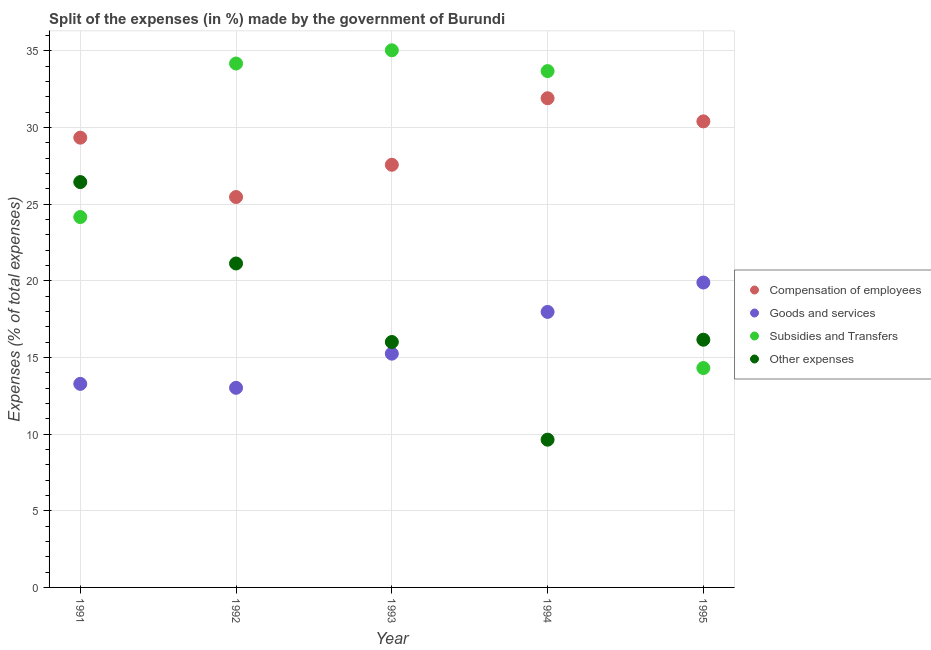What is the percentage of amount spent on compensation of employees in 1995?
Offer a very short reply. 30.4. Across all years, what is the maximum percentage of amount spent on goods and services?
Offer a terse response. 19.89. Across all years, what is the minimum percentage of amount spent on subsidies?
Provide a succinct answer. 14.31. In which year was the percentage of amount spent on goods and services maximum?
Your answer should be compact. 1995. In which year was the percentage of amount spent on compensation of employees minimum?
Provide a short and direct response. 1992. What is the total percentage of amount spent on subsidies in the graph?
Make the answer very short. 141.35. What is the difference between the percentage of amount spent on other expenses in 1991 and that in 1993?
Ensure brevity in your answer.  10.43. What is the difference between the percentage of amount spent on compensation of employees in 1992 and the percentage of amount spent on other expenses in 1991?
Make the answer very short. -0.98. What is the average percentage of amount spent on goods and services per year?
Your answer should be compact. 15.88. In the year 1991, what is the difference between the percentage of amount spent on other expenses and percentage of amount spent on goods and services?
Offer a very short reply. 13.16. In how many years, is the percentage of amount spent on compensation of employees greater than 22 %?
Offer a terse response. 5. What is the ratio of the percentage of amount spent on subsidies in 1991 to that in 1993?
Your response must be concise. 0.69. Is the percentage of amount spent on compensation of employees in 1993 less than that in 1994?
Your response must be concise. Yes. Is the difference between the percentage of amount spent on goods and services in 1992 and 1995 greater than the difference between the percentage of amount spent on compensation of employees in 1992 and 1995?
Make the answer very short. No. What is the difference between the highest and the second highest percentage of amount spent on other expenses?
Offer a terse response. 5.31. What is the difference between the highest and the lowest percentage of amount spent on goods and services?
Give a very brief answer. 6.87. In how many years, is the percentage of amount spent on goods and services greater than the average percentage of amount spent on goods and services taken over all years?
Offer a very short reply. 2. Is it the case that in every year, the sum of the percentage of amount spent on subsidies and percentage of amount spent on compensation of employees is greater than the sum of percentage of amount spent on goods and services and percentage of amount spent on other expenses?
Your answer should be compact. No. Is it the case that in every year, the sum of the percentage of amount spent on compensation of employees and percentage of amount spent on goods and services is greater than the percentage of amount spent on subsidies?
Give a very brief answer. Yes. Does the percentage of amount spent on goods and services monotonically increase over the years?
Provide a succinct answer. No. Is the percentage of amount spent on subsidies strictly greater than the percentage of amount spent on other expenses over the years?
Make the answer very short. No. Is the percentage of amount spent on subsidies strictly less than the percentage of amount spent on other expenses over the years?
Your answer should be compact. No. How many years are there in the graph?
Provide a succinct answer. 5. What is the difference between two consecutive major ticks on the Y-axis?
Your answer should be compact. 5. Where does the legend appear in the graph?
Your answer should be compact. Center right. What is the title of the graph?
Your response must be concise. Split of the expenses (in %) made by the government of Burundi. Does "PFC gas" appear as one of the legend labels in the graph?
Keep it short and to the point. No. What is the label or title of the X-axis?
Your answer should be very brief. Year. What is the label or title of the Y-axis?
Make the answer very short. Expenses (% of total expenses). What is the Expenses (% of total expenses) in Compensation of employees in 1991?
Provide a short and direct response. 29.34. What is the Expenses (% of total expenses) in Goods and services in 1991?
Your answer should be compact. 13.28. What is the Expenses (% of total expenses) in Subsidies and Transfers in 1991?
Make the answer very short. 24.16. What is the Expenses (% of total expenses) in Other expenses in 1991?
Provide a succinct answer. 26.44. What is the Expenses (% of total expenses) of Compensation of employees in 1992?
Keep it short and to the point. 25.46. What is the Expenses (% of total expenses) in Goods and services in 1992?
Provide a succinct answer. 13.02. What is the Expenses (% of total expenses) of Subsidies and Transfers in 1992?
Your answer should be compact. 34.17. What is the Expenses (% of total expenses) in Other expenses in 1992?
Keep it short and to the point. 21.13. What is the Expenses (% of total expenses) of Compensation of employees in 1993?
Keep it short and to the point. 27.57. What is the Expenses (% of total expenses) of Goods and services in 1993?
Keep it short and to the point. 15.25. What is the Expenses (% of total expenses) of Subsidies and Transfers in 1993?
Ensure brevity in your answer.  35.03. What is the Expenses (% of total expenses) of Other expenses in 1993?
Keep it short and to the point. 16.01. What is the Expenses (% of total expenses) in Compensation of employees in 1994?
Your answer should be very brief. 31.91. What is the Expenses (% of total expenses) of Goods and services in 1994?
Ensure brevity in your answer.  17.97. What is the Expenses (% of total expenses) in Subsidies and Transfers in 1994?
Give a very brief answer. 33.68. What is the Expenses (% of total expenses) of Other expenses in 1994?
Keep it short and to the point. 9.64. What is the Expenses (% of total expenses) of Compensation of employees in 1995?
Keep it short and to the point. 30.4. What is the Expenses (% of total expenses) in Goods and services in 1995?
Your response must be concise. 19.89. What is the Expenses (% of total expenses) of Subsidies and Transfers in 1995?
Offer a terse response. 14.31. What is the Expenses (% of total expenses) of Other expenses in 1995?
Ensure brevity in your answer.  16.16. Across all years, what is the maximum Expenses (% of total expenses) in Compensation of employees?
Your response must be concise. 31.91. Across all years, what is the maximum Expenses (% of total expenses) of Goods and services?
Provide a succinct answer. 19.89. Across all years, what is the maximum Expenses (% of total expenses) of Subsidies and Transfers?
Ensure brevity in your answer.  35.03. Across all years, what is the maximum Expenses (% of total expenses) of Other expenses?
Your answer should be compact. 26.44. Across all years, what is the minimum Expenses (% of total expenses) in Compensation of employees?
Your response must be concise. 25.46. Across all years, what is the minimum Expenses (% of total expenses) in Goods and services?
Your answer should be very brief. 13.02. Across all years, what is the minimum Expenses (% of total expenses) in Subsidies and Transfers?
Your answer should be very brief. 14.31. Across all years, what is the minimum Expenses (% of total expenses) of Other expenses?
Give a very brief answer. 9.64. What is the total Expenses (% of total expenses) of Compensation of employees in the graph?
Provide a succinct answer. 144.67. What is the total Expenses (% of total expenses) in Goods and services in the graph?
Make the answer very short. 79.4. What is the total Expenses (% of total expenses) of Subsidies and Transfers in the graph?
Make the answer very short. 141.35. What is the total Expenses (% of total expenses) of Other expenses in the graph?
Offer a very short reply. 89.37. What is the difference between the Expenses (% of total expenses) of Compensation of employees in 1991 and that in 1992?
Offer a terse response. 3.87. What is the difference between the Expenses (% of total expenses) in Goods and services in 1991 and that in 1992?
Provide a short and direct response. 0.26. What is the difference between the Expenses (% of total expenses) in Subsidies and Transfers in 1991 and that in 1992?
Your answer should be very brief. -10.01. What is the difference between the Expenses (% of total expenses) of Other expenses in 1991 and that in 1992?
Your answer should be very brief. 5.31. What is the difference between the Expenses (% of total expenses) in Compensation of employees in 1991 and that in 1993?
Your answer should be compact. 1.77. What is the difference between the Expenses (% of total expenses) in Goods and services in 1991 and that in 1993?
Keep it short and to the point. -1.97. What is the difference between the Expenses (% of total expenses) in Subsidies and Transfers in 1991 and that in 1993?
Your answer should be very brief. -10.88. What is the difference between the Expenses (% of total expenses) in Other expenses in 1991 and that in 1993?
Make the answer very short. 10.43. What is the difference between the Expenses (% of total expenses) in Compensation of employees in 1991 and that in 1994?
Make the answer very short. -2.57. What is the difference between the Expenses (% of total expenses) in Goods and services in 1991 and that in 1994?
Keep it short and to the point. -4.69. What is the difference between the Expenses (% of total expenses) of Subsidies and Transfers in 1991 and that in 1994?
Your response must be concise. -9.52. What is the difference between the Expenses (% of total expenses) of Other expenses in 1991 and that in 1994?
Ensure brevity in your answer.  16.8. What is the difference between the Expenses (% of total expenses) of Compensation of employees in 1991 and that in 1995?
Provide a succinct answer. -1.06. What is the difference between the Expenses (% of total expenses) in Goods and services in 1991 and that in 1995?
Offer a terse response. -6.61. What is the difference between the Expenses (% of total expenses) in Subsidies and Transfers in 1991 and that in 1995?
Your answer should be very brief. 9.85. What is the difference between the Expenses (% of total expenses) of Other expenses in 1991 and that in 1995?
Offer a terse response. 10.28. What is the difference between the Expenses (% of total expenses) of Compensation of employees in 1992 and that in 1993?
Your answer should be very brief. -2.1. What is the difference between the Expenses (% of total expenses) of Goods and services in 1992 and that in 1993?
Keep it short and to the point. -2.23. What is the difference between the Expenses (% of total expenses) of Subsidies and Transfers in 1992 and that in 1993?
Give a very brief answer. -0.86. What is the difference between the Expenses (% of total expenses) of Other expenses in 1992 and that in 1993?
Offer a very short reply. 5.12. What is the difference between the Expenses (% of total expenses) of Compensation of employees in 1992 and that in 1994?
Your answer should be very brief. -6.44. What is the difference between the Expenses (% of total expenses) in Goods and services in 1992 and that in 1994?
Give a very brief answer. -4.95. What is the difference between the Expenses (% of total expenses) of Subsidies and Transfers in 1992 and that in 1994?
Keep it short and to the point. 0.49. What is the difference between the Expenses (% of total expenses) in Other expenses in 1992 and that in 1994?
Keep it short and to the point. 11.49. What is the difference between the Expenses (% of total expenses) of Compensation of employees in 1992 and that in 1995?
Your answer should be very brief. -4.93. What is the difference between the Expenses (% of total expenses) in Goods and services in 1992 and that in 1995?
Provide a short and direct response. -6.87. What is the difference between the Expenses (% of total expenses) of Subsidies and Transfers in 1992 and that in 1995?
Your answer should be compact. 19.86. What is the difference between the Expenses (% of total expenses) of Other expenses in 1992 and that in 1995?
Provide a succinct answer. 4.97. What is the difference between the Expenses (% of total expenses) in Compensation of employees in 1993 and that in 1994?
Keep it short and to the point. -4.34. What is the difference between the Expenses (% of total expenses) of Goods and services in 1993 and that in 1994?
Ensure brevity in your answer.  -2.72. What is the difference between the Expenses (% of total expenses) of Subsidies and Transfers in 1993 and that in 1994?
Provide a succinct answer. 1.36. What is the difference between the Expenses (% of total expenses) in Other expenses in 1993 and that in 1994?
Offer a very short reply. 6.37. What is the difference between the Expenses (% of total expenses) of Compensation of employees in 1993 and that in 1995?
Give a very brief answer. -2.83. What is the difference between the Expenses (% of total expenses) in Goods and services in 1993 and that in 1995?
Provide a succinct answer. -4.64. What is the difference between the Expenses (% of total expenses) of Subsidies and Transfers in 1993 and that in 1995?
Offer a very short reply. 20.73. What is the difference between the Expenses (% of total expenses) of Other expenses in 1993 and that in 1995?
Provide a succinct answer. -0.15. What is the difference between the Expenses (% of total expenses) in Compensation of employees in 1994 and that in 1995?
Your response must be concise. 1.51. What is the difference between the Expenses (% of total expenses) of Goods and services in 1994 and that in 1995?
Your response must be concise. -1.92. What is the difference between the Expenses (% of total expenses) in Subsidies and Transfers in 1994 and that in 1995?
Keep it short and to the point. 19.37. What is the difference between the Expenses (% of total expenses) in Other expenses in 1994 and that in 1995?
Keep it short and to the point. -6.52. What is the difference between the Expenses (% of total expenses) in Compensation of employees in 1991 and the Expenses (% of total expenses) in Goods and services in 1992?
Your answer should be very brief. 16.32. What is the difference between the Expenses (% of total expenses) of Compensation of employees in 1991 and the Expenses (% of total expenses) of Subsidies and Transfers in 1992?
Give a very brief answer. -4.84. What is the difference between the Expenses (% of total expenses) of Compensation of employees in 1991 and the Expenses (% of total expenses) of Other expenses in 1992?
Offer a terse response. 8.21. What is the difference between the Expenses (% of total expenses) in Goods and services in 1991 and the Expenses (% of total expenses) in Subsidies and Transfers in 1992?
Your answer should be very brief. -20.89. What is the difference between the Expenses (% of total expenses) of Goods and services in 1991 and the Expenses (% of total expenses) of Other expenses in 1992?
Ensure brevity in your answer.  -7.85. What is the difference between the Expenses (% of total expenses) in Subsidies and Transfers in 1991 and the Expenses (% of total expenses) in Other expenses in 1992?
Keep it short and to the point. 3.03. What is the difference between the Expenses (% of total expenses) in Compensation of employees in 1991 and the Expenses (% of total expenses) in Goods and services in 1993?
Offer a terse response. 14.09. What is the difference between the Expenses (% of total expenses) in Compensation of employees in 1991 and the Expenses (% of total expenses) in Subsidies and Transfers in 1993?
Offer a very short reply. -5.7. What is the difference between the Expenses (% of total expenses) of Compensation of employees in 1991 and the Expenses (% of total expenses) of Other expenses in 1993?
Provide a short and direct response. 13.33. What is the difference between the Expenses (% of total expenses) in Goods and services in 1991 and the Expenses (% of total expenses) in Subsidies and Transfers in 1993?
Your answer should be compact. -21.76. What is the difference between the Expenses (% of total expenses) in Goods and services in 1991 and the Expenses (% of total expenses) in Other expenses in 1993?
Your answer should be very brief. -2.73. What is the difference between the Expenses (% of total expenses) in Subsidies and Transfers in 1991 and the Expenses (% of total expenses) in Other expenses in 1993?
Provide a succinct answer. 8.15. What is the difference between the Expenses (% of total expenses) in Compensation of employees in 1991 and the Expenses (% of total expenses) in Goods and services in 1994?
Offer a terse response. 11.37. What is the difference between the Expenses (% of total expenses) in Compensation of employees in 1991 and the Expenses (% of total expenses) in Subsidies and Transfers in 1994?
Offer a very short reply. -4.34. What is the difference between the Expenses (% of total expenses) in Compensation of employees in 1991 and the Expenses (% of total expenses) in Other expenses in 1994?
Keep it short and to the point. 19.7. What is the difference between the Expenses (% of total expenses) in Goods and services in 1991 and the Expenses (% of total expenses) in Subsidies and Transfers in 1994?
Provide a succinct answer. -20.4. What is the difference between the Expenses (% of total expenses) of Goods and services in 1991 and the Expenses (% of total expenses) of Other expenses in 1994?
Your answer should be compact. 3.64. What is the difference between the Expenses (% of total expenses) in Subsidies and Transfers in 1991 and the Expenses (% of total expenses) in Other expenses in 1994?
Keep it short and to the point. 14.52. What is the difference between the Expenses (% of total expenses) of Compensation of employees in 1991 and the Expenses (% of total expenses) of Goods and services in 1995?
Provide a short and direct response. 9.45. What is the difference between the Expenses (% of total expenses) in Compensation of employees in 1991 and the Expenses (% of total expenses) in Subsidies and Transfers in 1995?
Provide a succinct answer. 15.03. What is the difference between the Expenses (% of total expenses) of Compensation of employees in 1991 and the Expenses (% of total expenses) of Other expenses in 1995?
Give a very brief answer. 13.18. What is the difference between the Expenses (% of total expenses) in Goods and services in 1991 and the Expenses (% of total expenses) in Subsidies and Transfers in 1995?
Offer a very short reply. -1.03. What is the difference between the Expenses (% of total expenses) in Goods and services in 1991 and the Expenses (% of total expenses) in Other expenses in 1995?
Give a very brief answer. -2.88. What is the difference between the Expenses (% of total expenses) in Subsidies and Transfers in 1991 and the Expenses (% of total expenses) in Other expenses in 1995?
Give a very brief answer. 8. What is the difference between the Expenses (% of total expenses) of Compensation of employees in 1992 and the Expenses (% of total expenses) of Goods and services in 1993?
Your answer should be very brief. 10.22. What is the difference between the Expenses (% of total expenses) of Compensation of employees in 1992 and the Expenses (% of total expenses) of Subsidies and Transfers in 1993?
Keep it short and to the point. -9.57. What is the difference between the Expenses (% of total expenses) of Compensation of employees in 1992 and the Expenses (% of total expenses) of Other expenses in 1993?
Your answer should be compact. 9.46. What is the difference between the Expenses (% of total expenses) in Goods and services in 1992 and the Expenses (% of total expenses) in Subsidies and Transfers in 1993?
Ensure brevity in your answer.  -22.01. What is the difference between the Expenses (% of total expenses) of Goods and services in 1992 and the Expenses (% of total expenses) of Other expenses in 1993?
Keep it short and to the point. -2.99. What is the difference between the Expenses (% of total expenses) in Subsidies and Transfers in 1992 and the Expenses (% of total expenses) in Other expenses in 1993?
Provide a succinct answer. 18.16. What is the difference between the Expenses (% of total expenses) of Compensation of employees in 1992 and the Expenses (% of total expenses) of Goods and services in 1994?
Offer a very short reply. 7.49. What is the difference between the Expenses (% of total expenses) in Compensation of employees in 1992 and the Expenses (% of total expenses) in Subsidies and Transfers in 1994?
Ensure brevity in your answer.  -8.21. What is the difference between the Expenses (% of total expenses) of Compensation of employees in 1992 and the Expenses (% of total expenses) of Other expenses in 1994?
Your answer should be compact. 15.83. What is the difference between the Expenses (% of total expenses) of Goods and services in 1992 and the Expenses (% of total expenses) of Subsidies and Transfers in 1994?
Your answer should be very brief. -20.66. What is the difference between the Expenses (% of total expenses) of Goods and services in 1992 and the Expenses (% of total expenses) of Other expenses in 1994?
Keep it short and to the point. 3.38. What is the difference between the Expenses (% of total expenses) of Subsidies and Transfers in 1992 and the Expenses (% of total expenses) of Other expenses in 1994?
Offer a very short reply. 24.53. What is the difference between the Expenses (% of total expenses) of Compensation of employees in 1992 and the Expenses (% of total expenses) of Goods and services in 1995?
Give a very brief answer. 5.58. What is the difference between the Expenses (% of total expenses) in Compensation of employees in 1992 and the Expenses (% of total expenses) in Subsidies and Transfers in 1995?
Provide a succinct answer. 11.15. What is the difference between the Expenses (% of total expenses) in Compensation of employees in 1992 and the Expenses (% of total expenses) in Other expenses in 1995?
Give a very brief answer. 9.31. What is the difference between the Expenses (% of total expenses) of Goods and services in 1992 and the Expenses (% of total expenses) of Subsidies and Transfers in 1995?
Offer a very short reply. -1.29. What is the difference between the Expenses (% of total expenses) of Goods and services in 1992 and the Expenses (% of total expenses) of Other expenses in 1995?
Keep it short and to the point. -3.14. What is the difference between the Expenses (% of total expenses) of Subsidies and Transfers in 1992 and the Expenses (% of total expenses) of Other expenses in 1995?
Your answer should be very brief. 18.02. What is the difference between the Expenses (% of total expenses) of Compensation of employees in 1993 and the Expenses (% of total expenses) of Goods and services in 1994?
Provide a short and direct response. 9.6. What is the difference between the Expenses (% of total expenses) of Compensation of employees in 1993 and the Expenses (% of total expenses) of Subsidies and Transfers in 1994?
Ensure brevity in your answer.  -6.11. What is the difference between the Expenses (% of total expenses) of Compensation of employees in 1993 and the Expenses (% of total expenses) of Other expenses in 1994?
Make the answer very short. 17.93. What is the difference between the Expenses (% of total expenses) in Goods and services in 1993 and the Expenses (% of total expenses) in Subsidies and Transfers in 1994?
Your answer should be very brief. -18.43. What is the difference between the Expenses (% of total expenses) in Goods and services in 1993 and the Expenses (% of total expenses) in Other expenses in 1994?
Offer a terse response. 5.61. What is the difference between the Expenses (% of total expenses) in Subsidies and Transfers in 1993 and the Expenses (% of total expenses) in Other expenses in 1994?
Your answer should be compact. 25.4. What is the difference between the Expenses (% of total expenses) of Compensation of employees in 1993 and the Expenses (% of total expenses) of Goods and services in 1995?
Ensure brevity in your answer.  7.68. What is the difference between the Expenses (% of total expenses) in Compensation of employees in 1993 and the Expenses (% of total expenses) in Subsidies and Transfers in 1995?
Your answer should be very brief. 13.26. What is the difference between the Expenses (% of total expenses) in Compensation of employees in 1993 and the Expenses (% of total expenses) in Other expenses in 1995?
Your answer should be very brief. 11.41. What is the difference between the Expenses (% of total expenses) in Goods and services in 1993 and the Expenses (% of total expenses) in Subsidies and Transfers in 1995?
Your answer should be very brief. 0.94. What is the difference between the Expenses (% of total expenses) of Goods and services in 1993 and the Expenses (% of total expenses) of Other expenses in 1995?
Keep it short and to the point. -0.91. What is the difference between the Expenses (% of total expenses) of Subsidies and Transfers in 1993 and the Expenses (% of total expenses) of Other expenses in 1995?
Offer a terse response. 18.88. What is the difference between the Expenses (% of total expenses) in Compensation of employees in 1994 and the Expenses (% of total expenses) in Goods and services in 1995?
Your answer should be compact. 12.02. What is the difference between the Expenses (% of total expenses) in Compensation of employees in 1994 and the Expenses (% of total expenses) in Subsidies and Transfers in 1995?
Give a very brief answer. 17.6. What is the difference between the Expenses (% of total expenses) in Compensation of employees in 1994 and the Expenses (% of total expenses) in Other expenses in 1995?
Your response must be concise. 15.75. What is the difference between the Expenses (% of total expenses) in Goods and services in 1994 and the Expenses (% of total expenses) in Subsidies and Transfers in 1995?
Make the answer very short. 3.66. What is the difference between the Expenses (% of total expenses) in Goods and services in 1994 and the Expenses (% of total expenses) in Other expenses in 1995?
Offer a terse response. 1.81. What is the difference between the Expenses (% of total expenses) of Subsidies and Transfers in 1994 and the Expenses (% of total expenses) of Other expenses in 1995?
Ensure brevity in your answer.  17.52. What is the average Expenses (% of total expenses) in Compensation of employees per year?
Provide a short and direct response. 28.93. What is the average Expenses (% of total expenses) of Goods and services per year?
Give a very brief answer. 15.88. What is the average Expenses (% of total expenses) of Subsidies and Transfers per year?
Provide a short and direct response. 28.27. What is the average Expenses (% of total expenses) of Other expenses per year?
Your answer should be compact. 17.87. In the year 1991, what is the difference between the Expenses (% of total expenses) in Compensation of employees and Expenses (% of total expenses) in Goods and services?
Offer a terse response. 16.06. In the year 1991, what is the difference between the Expenses (% of total expenses) of Compensation of employees and Expenses (% of total expenses) of Subsidies and Transfers?
Your answer should be compact. 5.18. In the year 1991, what is the difference between the Expenses (% of total expenses) in Compensation of employees and Expenses (% of total expenses) in Other expenses?
Ensure brevity in your answer.  2.9. In the year 1991, what is the difference between the Expenses (% of total expenses) of Goods and services and Expenses (% of total expenses) of Subsidies and Transfers?
Offer a very short reply. -10.88. In the year 1991, what is the difference between the Expenses (% of total expenses) in Goods and services and Expenses (% of total expenses) in Other expenses?
Your response must be concise. -13.16. In the year 1991, what is the difference between the Expenses (% of total expenses) of Subsidies and Transfers and Expenses (% of total expenses) of Other expenses?
Your response must be concise. -2.28. In the year 1992, what is the difference between the Expenses (% of total expenses) in Compensation of employees and Expenses (% of total expenses) in Goods and services?
Offer a terse response. 12.44. In the year 1992, what is the difference between the Expenses (% of total expenses) in Compensation of employees and Expenses (% of total expenses) in Subsidies and Transfers?
Your response must be concise. -8.71. In the year 1992, what is the difference between the Expenses (% of total expenses) of Compensation of employees and Expenses (% of total expenses) of Other expenses?
Your response must be concise. 4.33. In the year 1992, what is the difference between the Expenses (% of total expenses) in Goods and services and Expenses (% of total expenses) in Subsidies and Transfers?
Your answer should be compact. -21.15. In the year 1992, what is the difference between the Expenses (% of total expenses) of Goods and services and Expenses (% of total expenses) of Other expenses?
Make the answer very short. -8.11. In the year 1992, what is the difference between the Expenses (% of total expenses) in Subsidies and Transfers and Expenses (% of total expenses) in Other expenses?
Offer a very short reply. 13.04. In the year 1993, what is the difference between the Expenses (% of total expenses) of Compensation of employees and Expenses (% of total expenses) of Goods and services?
Offer a terse response. 12.32. In the year 1993, what is the difference between the Expenses (% of total expenses) in Compensation of employees and Expenses (% of total expenses) in Subsidies and Transfers?
Give a very brief answer. -7.47. In the year 1993, what is the difference between the Expenses (% of total expenses) of Compensation of employees and Expenses (% of total expenses) of Other expenses?
Your response must be concise. 11.56. In the year 1993, what is the difference between the Expenses (% of total expenses) in Goods and services and Expenses (% of total expenses) in Subsidies and Transfers?
Your answer should be very brief. -19.79. In the year 1993, what is the difference between the Expenses (% of total expenses) in Goods and services and Expenses (% of total expenses) in Other expenses?
Offer a very short reply. -0.76. In the year 1993, what is the difference between the Expenses (% of total expenses) in Subsidies and Transfers and Expenses (% of total expenses) in Other expenses?
Offer a very short reply. 19.03. In the year 1994, what is the difference between the Expenses (% of total expenses) in Compensation of employees and Expenses (% of total expenses) in Goods and services?
Give a very brief answer. 13.94. In the year 1994, what is the difference between the Expenses (% of total expenses) of Compensation of employees and Expenses (% of total expenses) of Subsidies and Transfers?
Your answer should be compact. -1.77. In the year 1994, what is the difference between the Expenses (% of total expenses) of Compensation of employees and Expenses (% of total expenses) of Other expenses?
Give a very brief answer. 22.27. In the year 1994, what is the difference between the Expenses (% of total expenses) of Goods and services and Expenses (% of total expenses) of Subsidies and Transfers?
Your answer should be compact. -15.71. In the year 1994, what is the difference between the Expenses (% of total expenses) in Goods and services and Expenses (% of total expenses) in Other expenses?
Your answer should be very brief. 8.33. In the year 1994, what is the difference between the Expenses (% of total expenses) in Subsidies and Transfers and Expenses (% of total expenses) in Other expenses?
Give a very brief answer. 24.04. In the year 1995, what is the difference between the Expenses (% of total expenses) of Compensation of employees and Expenses (% of total expenses) of Goods and services?
Provide a succinct answer. 10.51. In the year 1995, what is the difference between the Expenses (% of total expenses) in Compensation of employees and Expenses (% of total expenses) in Subsidies and Transfers?
Your answer should be very brief. 16.09. In the year 1995, what is the difference between the Expenses (% of total expenses) of Compensation of employees and Expenses (% of total expenses) of Other expenses?
Ensure brevity in your answer.  14.24. In the year 1995, what is the difference between the Expenses (% of total expenses) in Goods and services and Expenses (% of total expenses) in Subsidies and Transfers?
Provide a succinct answer. 5.58. In the year 1995, what is the difference between the Expenses (% of total expenses) in Goods and services and Expenses (% of total expenses) in Other expenses?
Make the answer very short. 3.73. In the year 1995, what is the difference between the Expenses (% of total expenses) in Subsidies and Transfers and Expenses (% of total expenses) in Other expenses?
Your response must be concise. -1.85. What is the ratio of the Expenses (% of total expenses) in Compensation of employees in 1991 to that in 1992?
Offer a very short reply. 1.15. What is the ratio of the Expenses (% of total expenses) of Goods and services in 1991 to that in 1992?
Keep it short and to the point. 1.02. What is the ratio of the Expenses (% of total expenses) in Subsidies and Transfers in 1991 to that in 1992?
Ensure brevity in your answer.  0.71. What is the ratio of the Expenses (% of total expenses) of Other expenses in 1991 to that in 1992?
Your answer should be compact. 1.25. What is the ratio of the Expenses (% of total expenses) of Compensation of employees in 1991 to that in 1993?
Ensure brevity in your answer.  1.06. What is the ratio of the Expenses (% of total expenses) in Goods and services in 1991 to that in 1993?
Provide a succinct answer. 0.87. What is the ratio of the Expenses (% of total expenses) of Subsidies and Transfers in 1991 to that in 1993?
Your response must be concise. 0.69. What is the ratio of the Expenses (% of total expenses) of Other expenses in 1991 to that in 1993?
Give a very brief answer. 1.65. What is the ratio of the Expenses (% of total expenses) of Compensation of employees in 1991 to that in 1994?
Give a very brief answer. 0.92. What is the ratio of the Expenses (% of total expenses) of Goods and services in 1991 to that in 1994?
Provide a short and direct response. 0.74. What is the ratio of the Expenses (% of total expenses) in Subsidies and Transfers in 1991 to that in 1994?
Your response must be concise. 0.72. What is the ratio of the Expenses (% of total expenses) in Other expenses in 1991 to that in 1994?
Your answer should be very brief. 2.74. What is the ratio of the Expenses (% of total expenses) in Goods and services in 1991 to that in 1995?
Offer a very short reply. 0.67. What is the ratio of the Expenses (% of total expenses) in Subsidies and Transfers in 1991 to that in 1995?
Your response must be concise. 1.69. What is the ratio of the Expenses (% of total expenses) of Other expenses in 1991 to that in 1995?
Offer a very short reply. 1.64. What is the ratio of the Expenses (% of total expenses) of Compensation of employees in 1992 to that in 1993?
Ensure brevity in your answer.  0.92. What is the ratio of the Expenses (% of total expenses) in Goods and services in 1992 to that in 1993?
Provide a short and direct response. 0.85. What is the ratio of the Expenses (% of total expenses) of Subsidies and Transfers in 1992 to that in 1993?
Provide a short and direct response. 0.98. What is the ratio of the Expenses (% of total expenses) in Other expenses in 1992 to that in 1993?
Your response must be concise. 1.32. What is the ratio of the Expenses (% of total expenses) of Compensation of employees in 1992 to that in 1994?
Ensure brevity in your answer.  0.8. What is the ratio of the Expenses (% of total expenses) of Goods and services in 1992 to that in 1994?
Your answer should be compact. 0.72. What is the ratio of the Expenses (% of total expenses) in Subsidies and Transfers in 1992 to that in 1994?
Provide a succinct answer. 1.01. What is the ratio of the Expenses (% of total expenses) of Other expenses in 1992 to that in 1994?
Your response must be concise. 2.19. What is the ratio of the Expenses (% of total expenses) in Compensation of employees in 1992 to that in 1995?
Ensure brevity in your answer.  0.84. What is the ratio of the Expenses (% of total expenses) of Goods and services in 1992 to that in 1995?
Your response must be concise. 0.65. What is the ratio of the Expenses (% of total expenses) of Subsidies and Transfers in 1992 to that in 1995?
Ensure brevity in your answer.  2.39. What is the ratio of the Expenses (% of total expenses) of Other expenses in 1992 to that in 1995?
Your answer should be compact. 1.31. What is the ratio of the Expenses (% of total expenses) of Compensation of employees in 1993 to that in 1994?
Give a very brief answer. 0.86. What is the ratio of the Expenses (% of total expenses) in Goods and services in 1993 to that in 1994?
Provide a short and direct response. 0.85. What is the ratio of the Expenses (% of total expenses) of Subsidies and Transfers in 1993 to that in 1994?
Offer a very short reply. 1.04. What is the ratio of the Expenses (% of total expenses) of Other expenses in 1993 to that in 1994?
Your response must be concise. 1.66. What is the ratio of the Expenses (% of total expenses) in Compensation of employees in 1993 to that in 1995?
Give a very brief answer. 0.91. What is the ratio of the Expenses (% of total expenses) of Goods and services in 1993 to that in 1995?
Keep it short and to the point. 0.77. What is the ratio of the Expenses (% of total expenses) of Subsidies and Transfers in 1993 to that in 1995?
Your answer should be very brief. 2.45. What is the ratio of the Expenses (% of total expenses) of Compensation of employees in 1994 to that in 1995?
Make the answer very short. 1.05. What is the ratio of the Expenses (% of total expenses) of Goods and services in 1994 to that in 1995?
Provide a short and direct response. 0.9. What is the ratio of the Expenses (% of total expenses) of Subsidies and Transfers in 1994 to that in 1995?
Provide a short and direct response. 2.35. What is the ratio of the Expenses (% of total expenses) of Other expenses in 1994 to that in 1995?
Provide a succinct answer. 0.6. What is the difference between the highest and the second highest Expenses (% of total expenses) in Compensation of employees?
Make the answer very short. 1.51. What is the difference between the highest and the second highest Expenses (% of total expenses) of Goods and services?
Provide a short and direct response. 1.92. What is the difference between the highest and the second highest Expenses (% of total expenses) in Subsidies and Transfers?
Ensure brevity in your answer.  0.86. What is the difference between the highest and the second highest Expenses (% of total expenses) of Other expenses?
Offer a very short reply. 5.31. What is the difference between the highest and the lowest Expenses (% of total expenses) in Compensation of employees?
Make the answer very short. 6.44. What is the difference between the highest and the lowest Expenses (% of total expenses) in Goods and services?
Provide a succinct answer. 6.87. What is the difference between the highest and the lowest Expenses (% of total expenses) in Subsidies and Transfers?
Offer a very short reply. 20.73. What is the difference between the highest and the lowest Expenses (% of total expenses) in Other expenses?
Offer a very short reply. 16.8. 